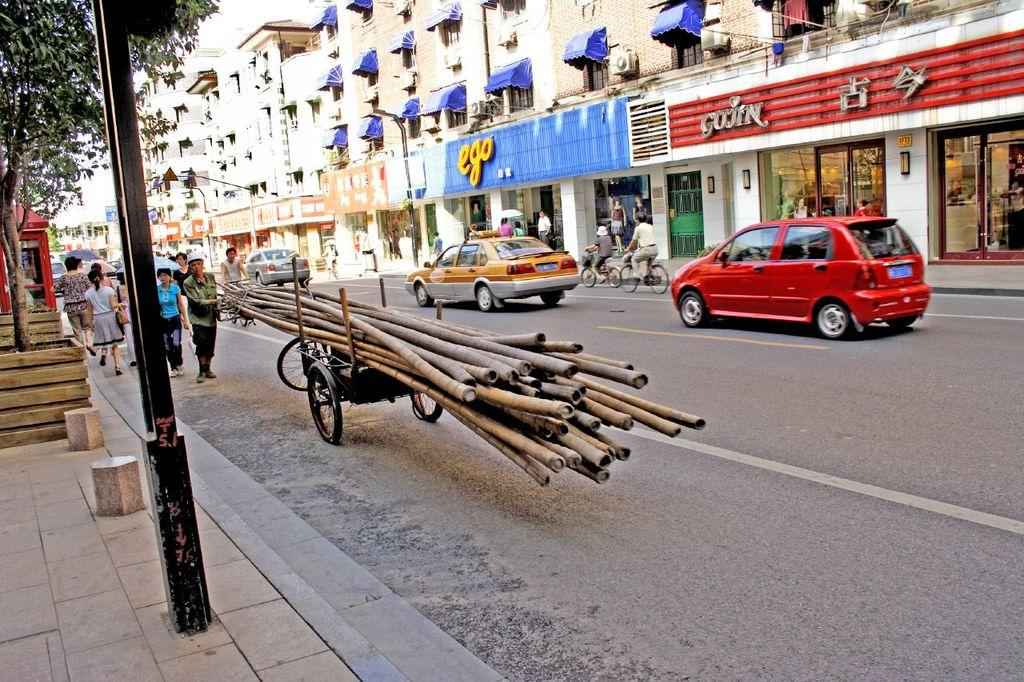<image>
Create a compact narrative representing the image presented. Behind a street in yellow is a store called ego. 